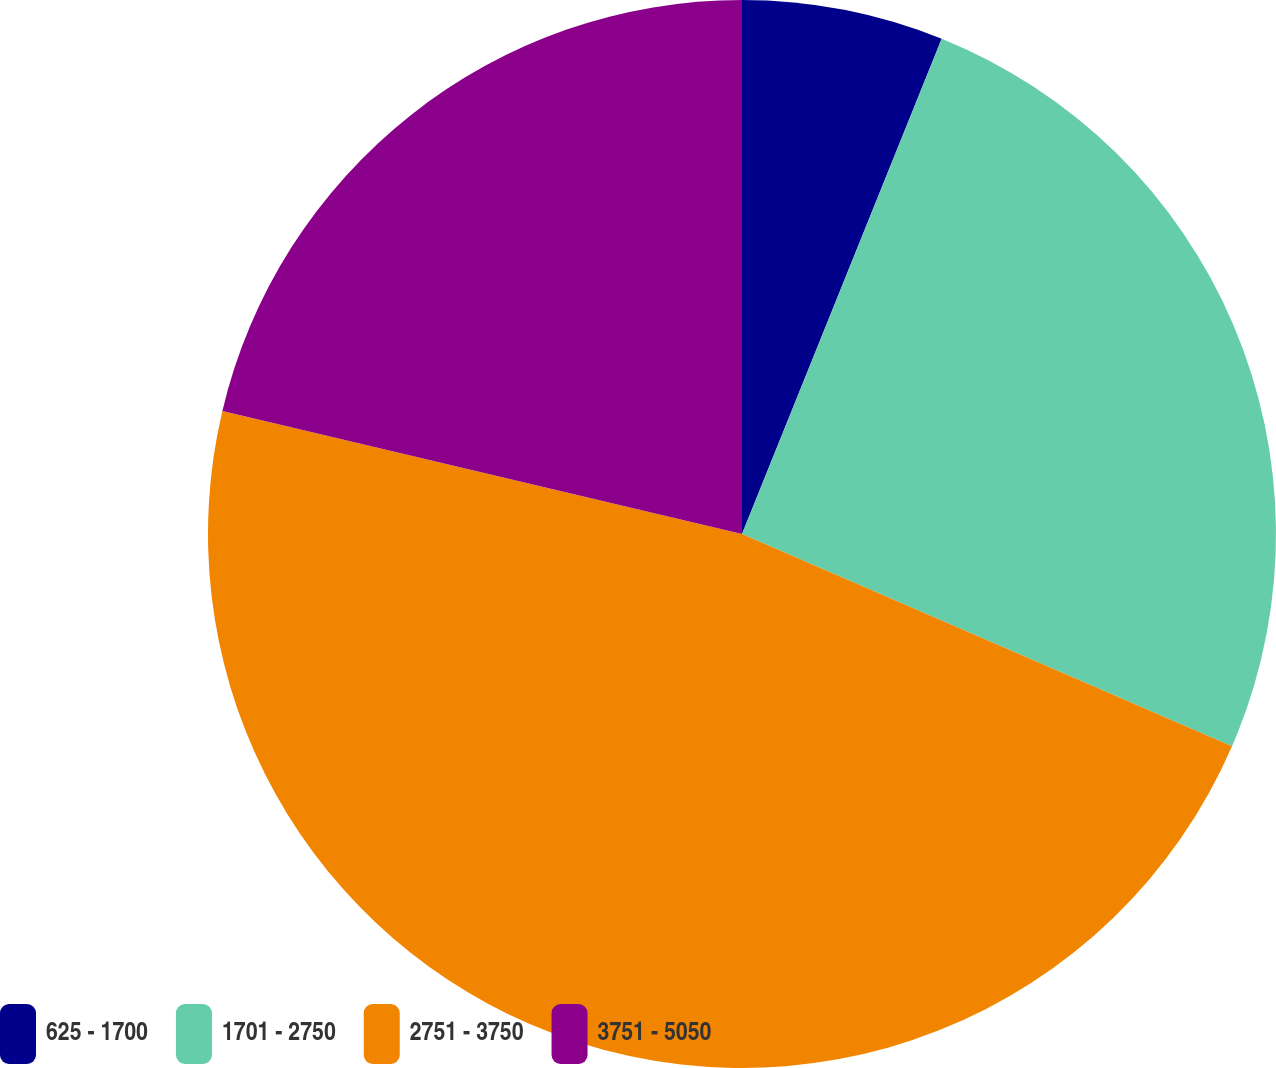Convert chart to OTSL. <chart><loc_0><loc_0><loc_500><loc_500><pie_chart><fcel>625 - 1700<fcel>1701 - 2750<fcel>2751 - 3750<fcel>3751 - 5050<nl><fcel>6.1%<fcel>25.41%<fcel>47.2%<fcel>21.3%<nl></chart> 